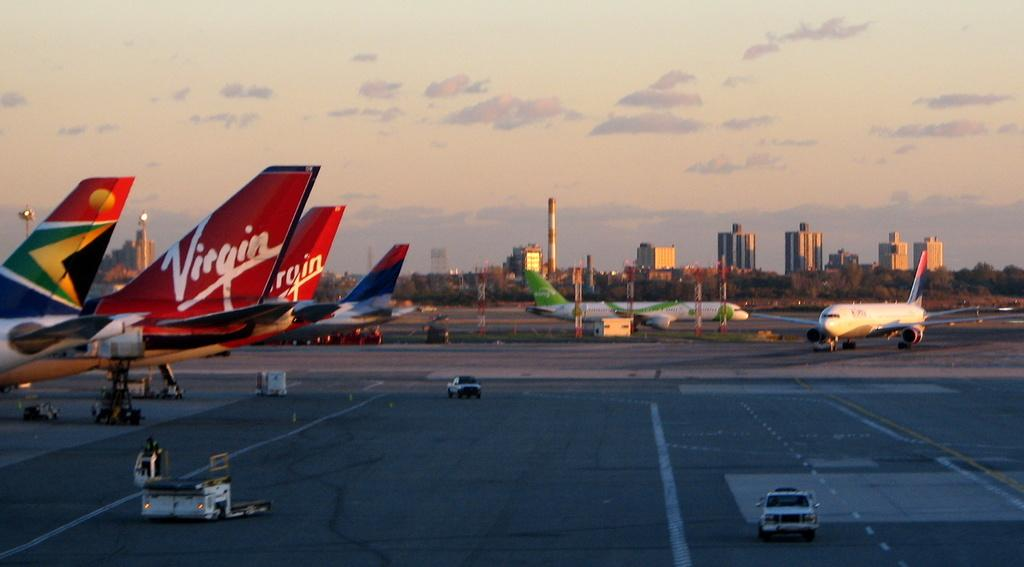<image>
Provide a brief description of the given image. Two Virgin Airlines planes sit on the tarmac. 